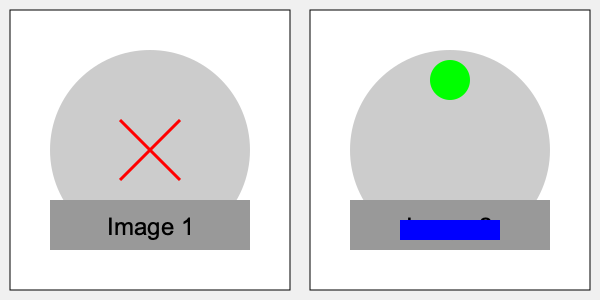In these behind-the-scenes images from the Grey's Anatomy set, how many differences can you spot between Image 1 and Image 2? To find the differences between the two images, we need to carefully compare them:

1. In Image 1, there's a red X-shaped mark in the center of the circular area. This mark is absent in Image 2.
2. Image 2 has a green circle near the top of the circular area, which is not present in Image 1.
3. In Image 2, there's a blue rectangle at the bottom of the image, overlapping the gray rectangle. This blue rectangle is not in Image 1.

These are the only visible differences between the two images. All other elements, including the overall layout, the large circular area, and the gray rectangle at the bottom, remain the same in both images.
Answer: 3 differences 